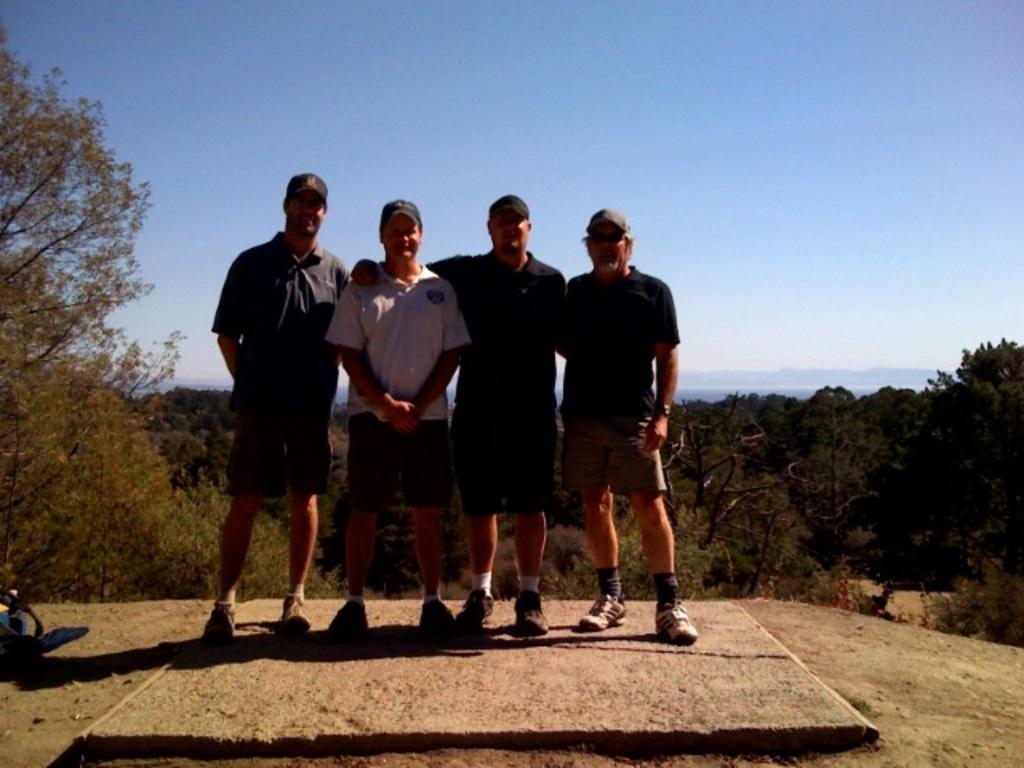What is the main subject of the image? The main subject of the image is men standing in the center. Where are the men standing? The men are standing on the ground. What can be seen in the background of the image? There are trees, water, hills, and the sky visible in the background. What type of brain is visible in the image? There is no brain present in the image. What organization is responsible for the men standing in the image? The image does not provide information about any organization responsible for the men standing. 